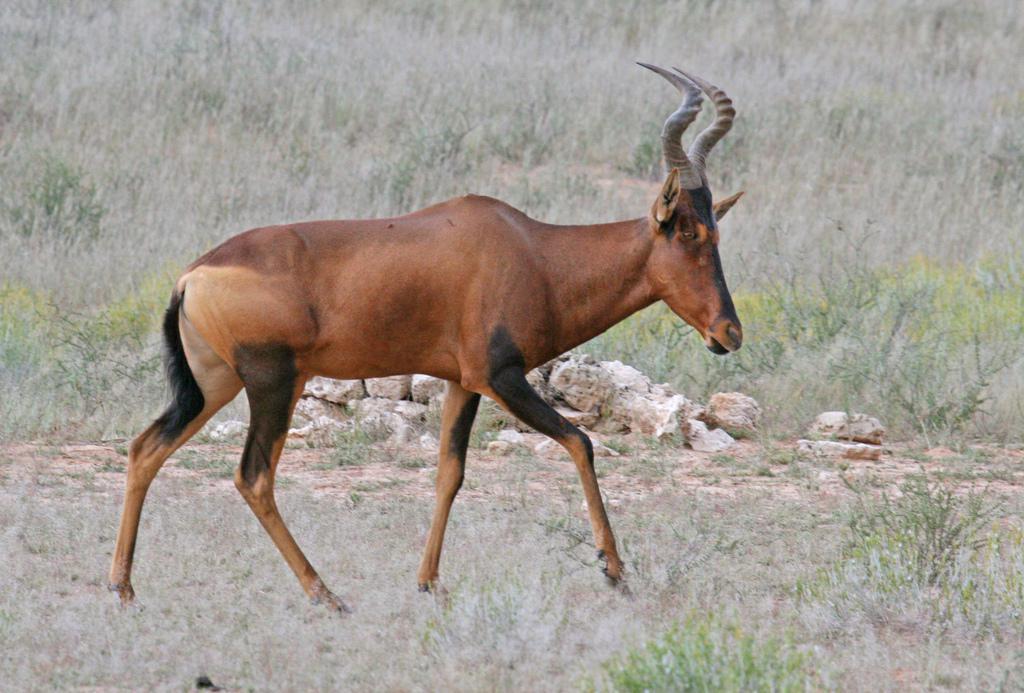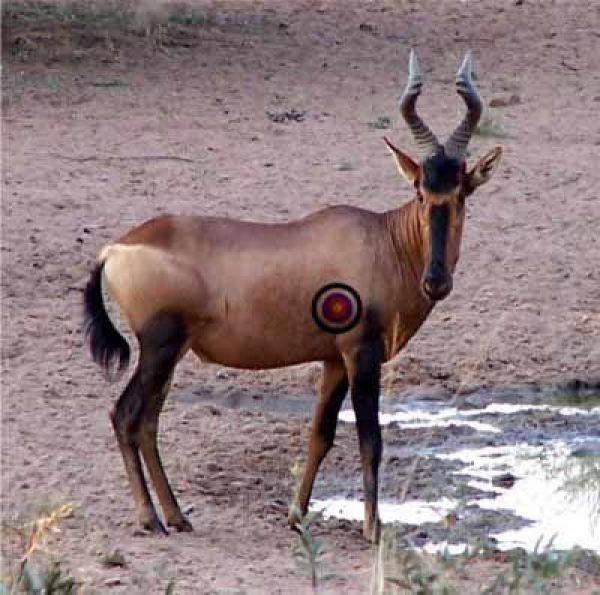The first image is the image on the left, the second image is the image on the right. Analyze the images presented: Is the assertion "In one of the images, there is an animal near water." valid? Answer yes or no. Yes. The first image is the image on the left, the second image is the image on the right. For the images displayed, is the sentence "There are exactly two horned animals standing in total." factually correct? Answer yes or no. Yes. 